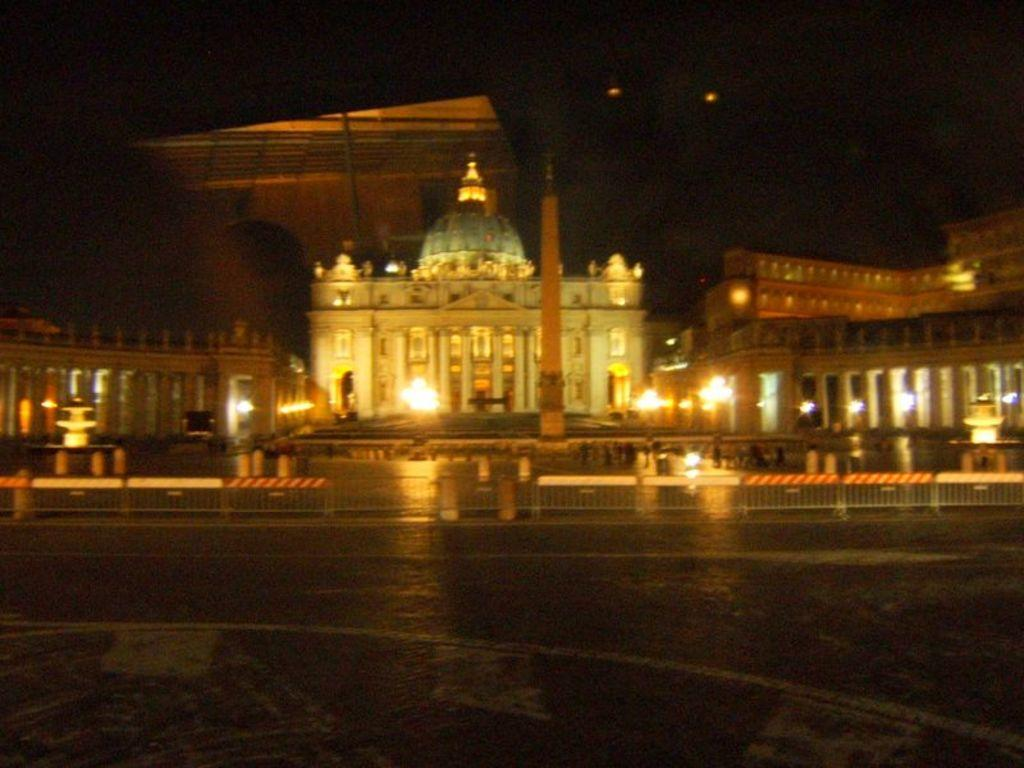What type of structures can be seen in the image? There are buildings in the image. What else is visible in the image besides the buildings? There are lights visible in the image, as well as a road and a monument. What is the lighting condition in the image? The background of the image appears dark. What type of fowl can be seen roaming around the monument in the image? There are no fowl present in the image; it only features buildings, lights, a road, and a monument. What channel is being broadcasted on the monument in the image? There is no channel being broadcasted on the monument in the image, as it is a physical structure and not a screen or device for displaying content. 